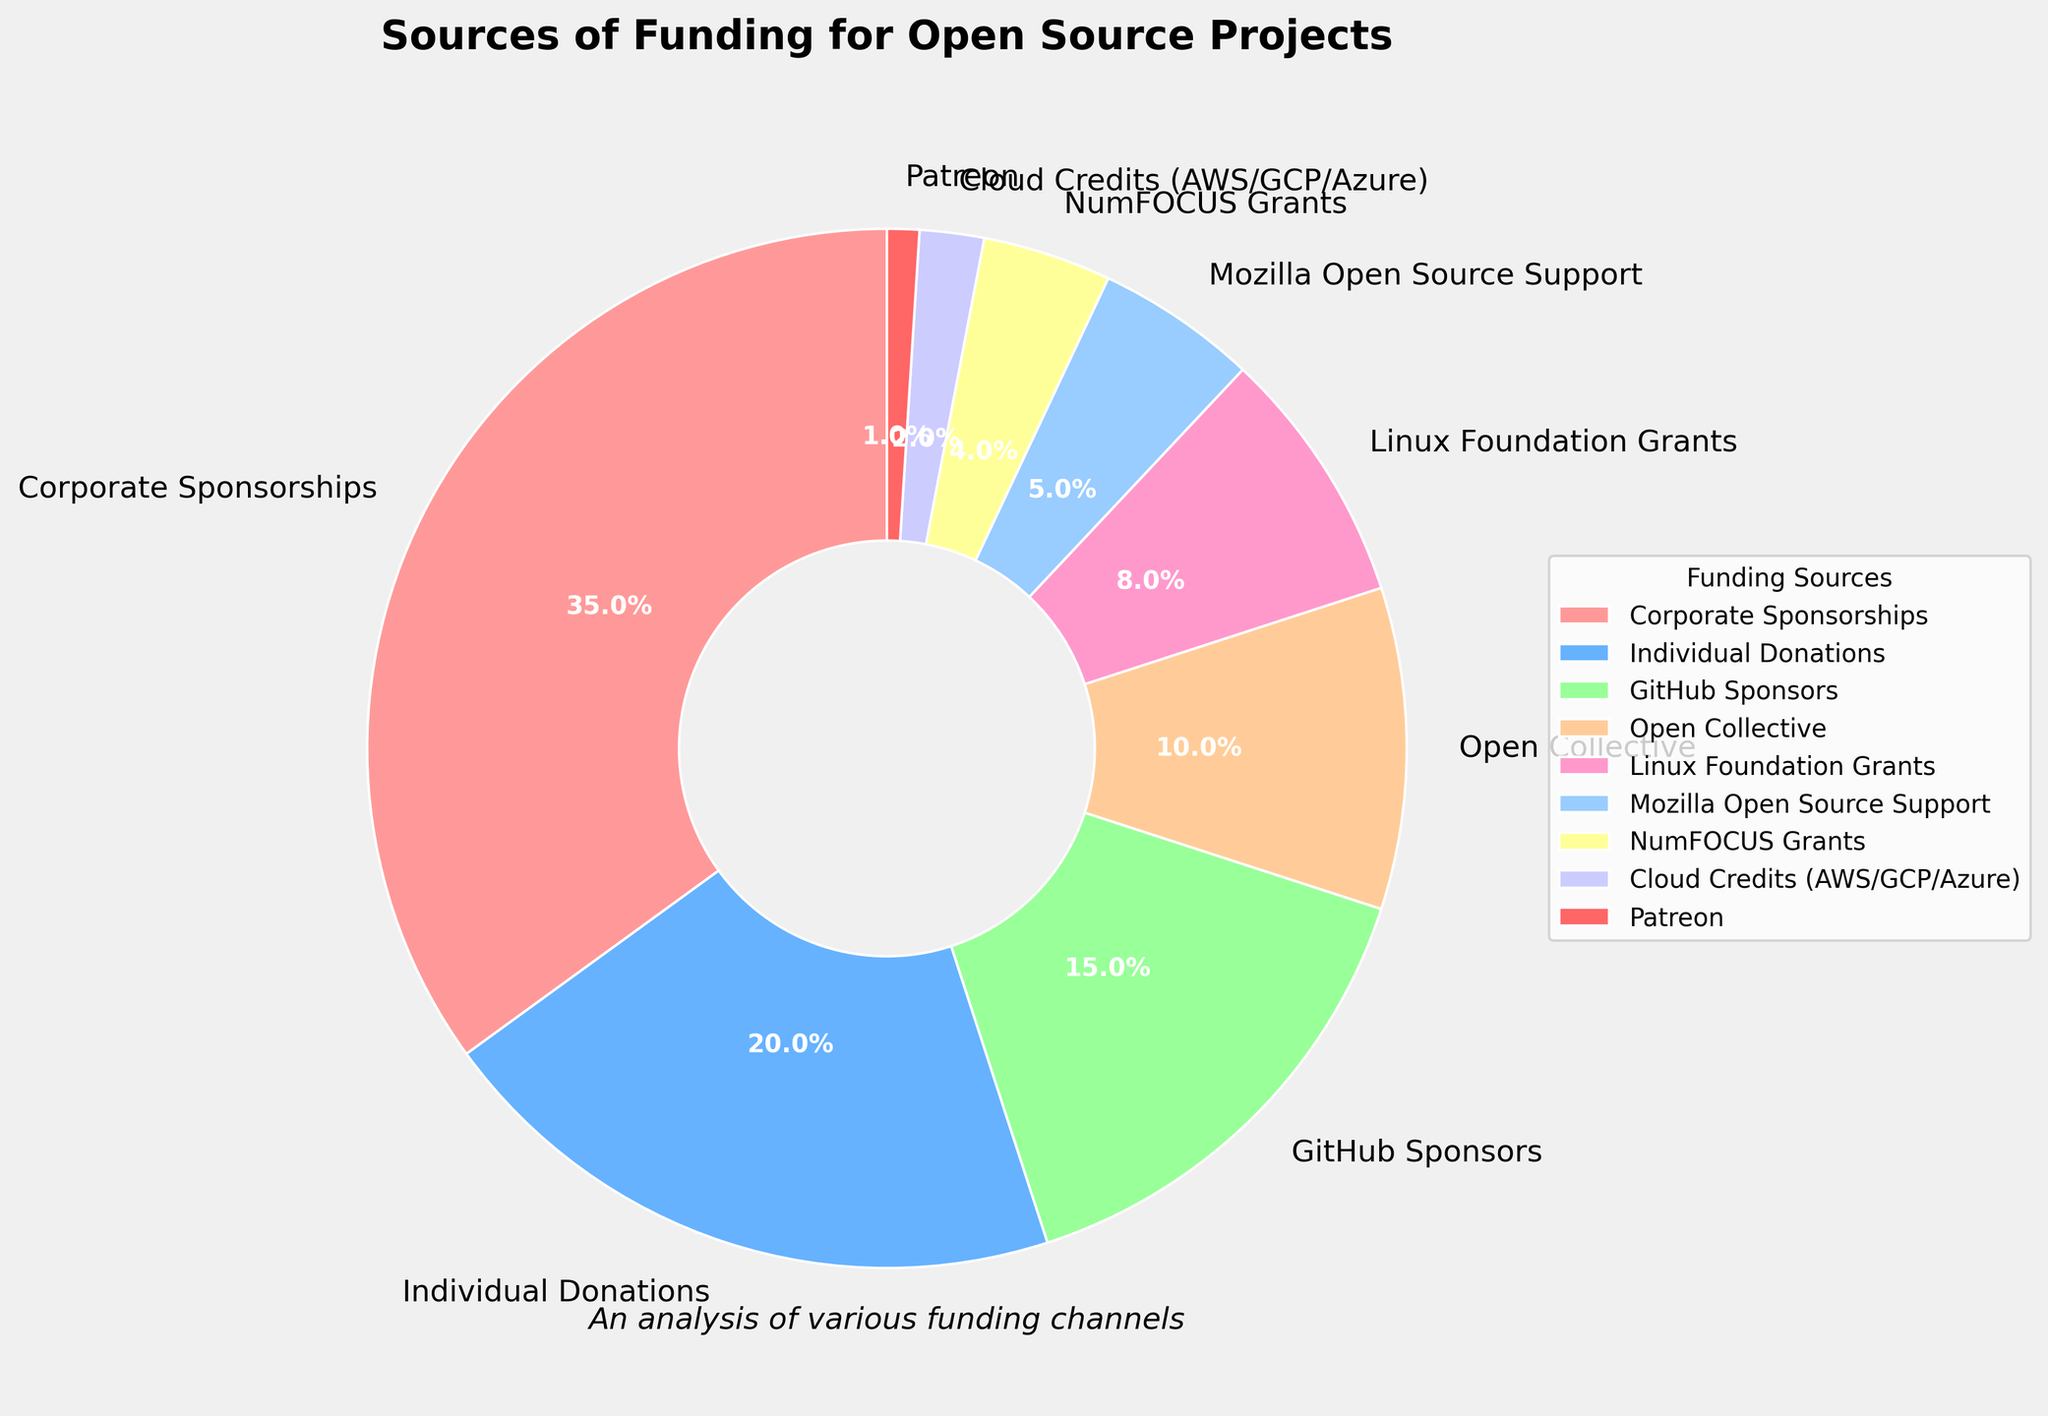Which funding source has the highest percentage? The funding source with the highest percentage is determined by looking at the segment of the pie chart with the largest area or the highest value in the labels.
Answer: Corporate Sponsorships Which funding source has the smallest percentage? The funding source with the smallest percentage is found by identifying the segment of the pie chart with the smallest area or the lowest value in the labels.
Answer: Patreon What is the combined percentage of the top two funding sources? The top two funding sources are Corporate Sponsorships (35%) and Individual Donations (20%). Add these percentages together: 35% + 20% = 55%.
Answer: 55% How does the percentage of GitHub Sponsors compare to Open Collective? Compare the percentage values of GitHub Sponsors (15%) and Open Collective (10%) to identify which is higher.
Answer: GitHub Sponsors has a higher percentage What is the total percentage contributed by Linux Foundation Grants, Mozilla Open Source Support, and NumFOCUS Grants? Add the percentages of Linux Foundation Grants (8%), Mozilla Open Source Support (5%), and NumFOCUS Grants (4%): 8% + 5% + 4% = 17%.
Answer: 17% Which funding source has a percentage closest to 10%? Identify the funding source with the percentage value closest to 10%. Open Collective is exactly 10%.
Answer: Open Collective Is the percentage contribution of Corporate Sponsorships more than double that of Individual Donations? Double the percentage of Individual Donations (20%) is 40%. Since Corporate Sponsorships is 35%, which is less than 40%, it is not more than double.
Answer: No What is the combined percentage of all sources less than 10%? Identify and add the percentages of all funding sources less than 10%: Open Collective (10%), Linux Foundation Grants (8%), Mozilla Open Source Support (5%), NumFOCUS Grants (4%), Cloud Credits (2%), and Patreon (1%): 8% + 5% + 4% + 2% + 1% = 20%.
Answer: 20% How many funding sources contribute more than 5% each? Count the segments that contribute more than 5%: Corporate Sponsorships (35%), Individual Donations (20%), GitHub Sponsors (15%), Open Collective (10%), and Linux Foundation Grants (8%) – 5 segments.
Answer: 5 What is the average percentage of the funding sources listed? Add all the percentages and divide by the number of funding sources: (35% + 20% + 15% + 10% + 8% + 5% + 4% + 2% + 1%) / 9 = 100% / 9 ≈ 11.1%.
Answer: 11.1% 